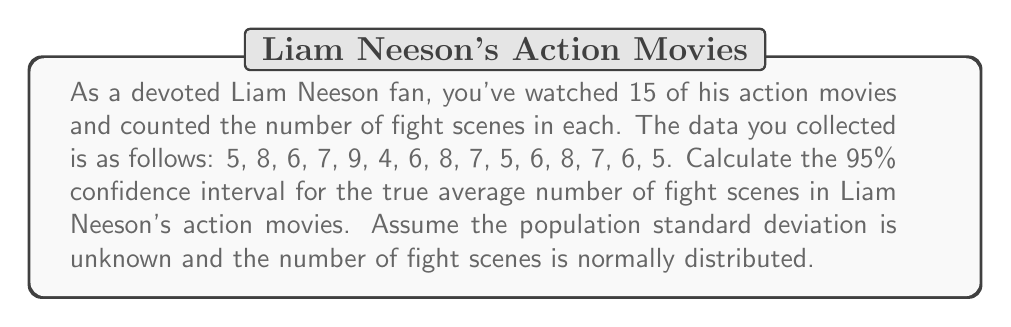Give your solution to this math problem. To calculate the 95% confidence interval, we'll use the t-distribution since the population standard deviation is unknown and we have a small sample size (n < 30). We'll follow these steps:

1. Calculate the sample mean ($\bar{x}$):
   $$\bar{x} = \frac{\sum_{i=1}^{n} x_i}{n} = \frac{97}{15} = 6.467$$

2. Calculate the sample standard deviation (s):
   $$s = \sqrt{\frac{\sum_{i=1}^{n} (x_i - \bar{x})^2}{n - 1}} = 1.407$$

3. Determine the degrees of freedom: df = n - 1 = 15 - 1 = 14

4. Find the t-critical value for a 95% confidence interval with 14 degrees of freedom:
   $t_{0.025, 14} = 2.145$ (from t-distribution table)

5. Calculate the margin of error:
   $$\text{Margin of Error} = t_{0.025, 14} \cdot \frac{s}{\sqrt{n}} = 2.145 \cdot \frac{1.407}{\sqrt{15}} = 0.780$$

6. Compute the confidence interval:
   $$\text{CI} = \bar{x} \pm \text{Margin of Error}$$
   $$\text{CI} = 6.467 \pm 0.780$$
   $$\text{CI} = (5.687, 7.247)$$
Answer: The 95% confidence interval for the true average number of fight scenes in Liam Neeson's action movies is (5.687, 7.247). 